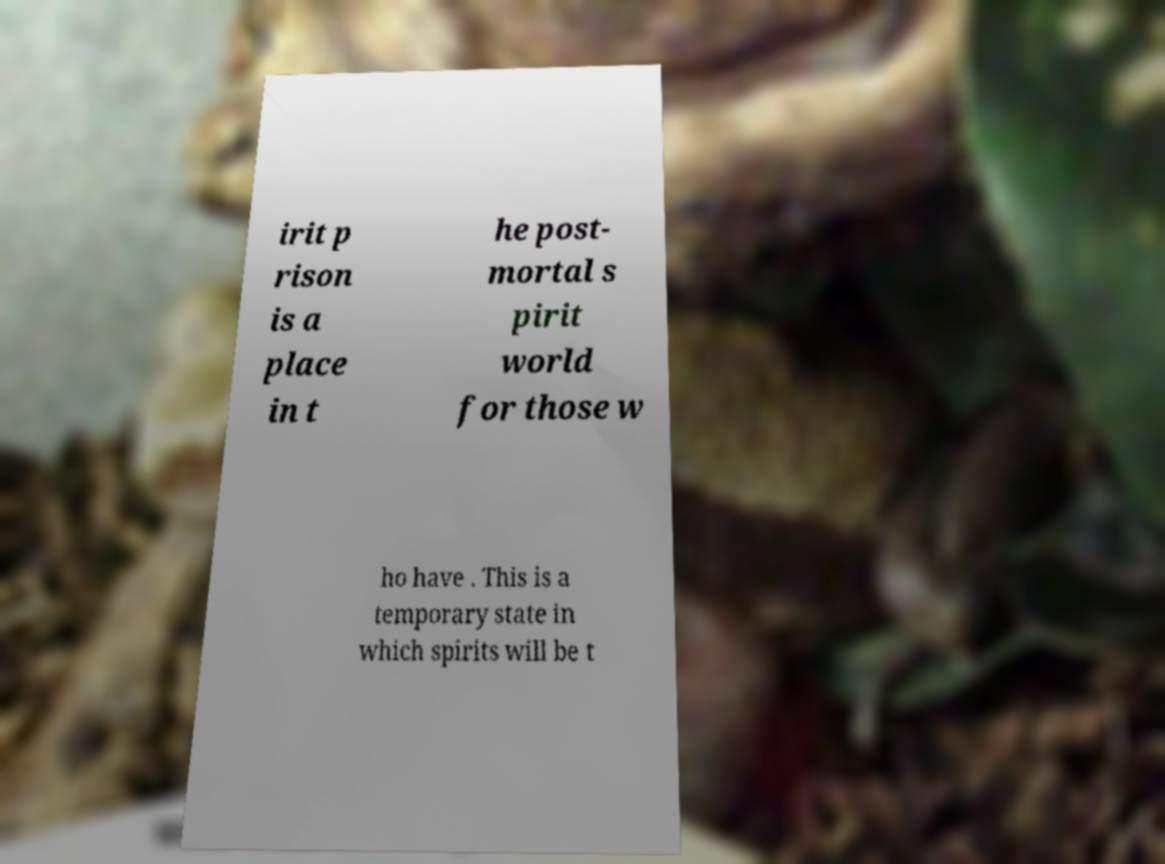Could you assist in decoding the text presented in this image and type it out clearly? irit p rison is a place in t he post- mortal s pirit world for those w ho have . This is a temporary state in which spirits will be t 